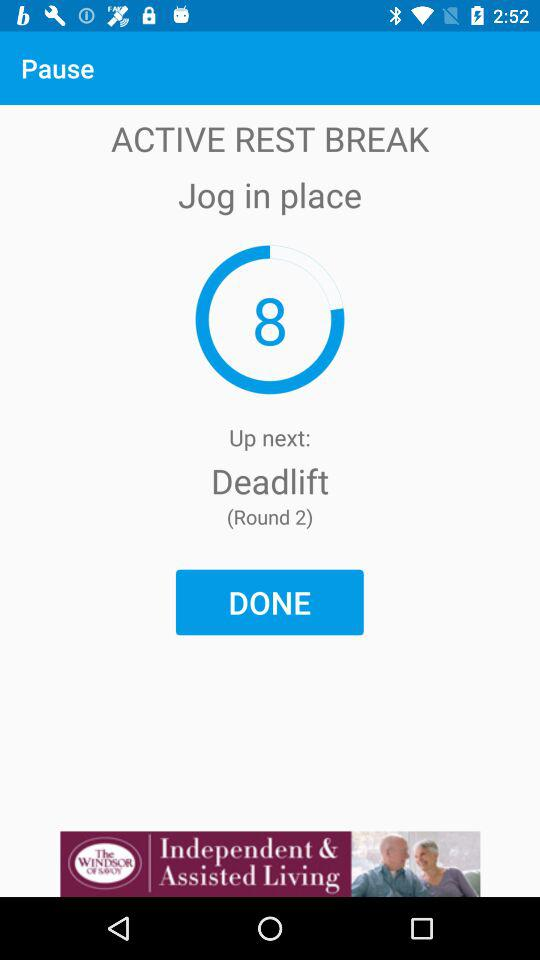How many rounds have I completed?
Answer the question using a single word or phrase. 2 